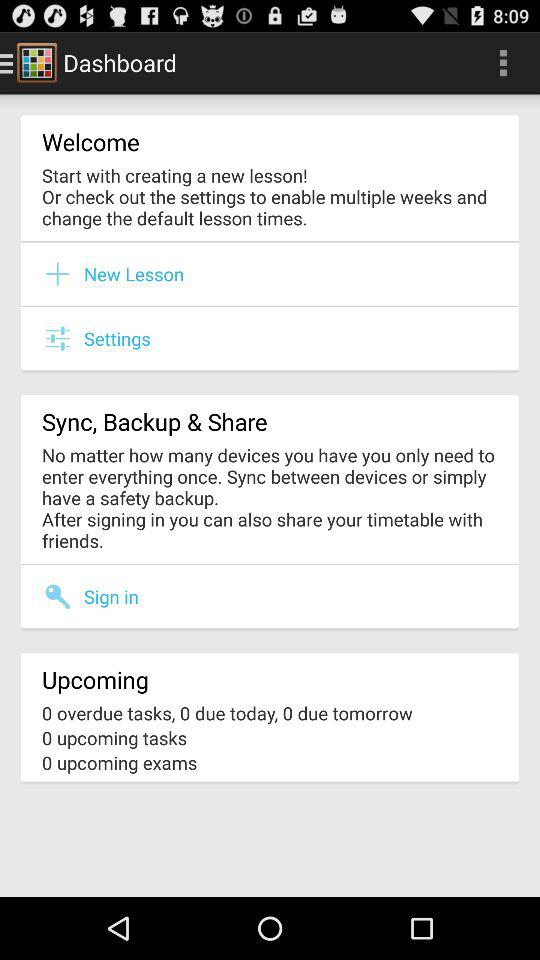What is the upcoming number of exams? The upcoming number of exams is 0. 